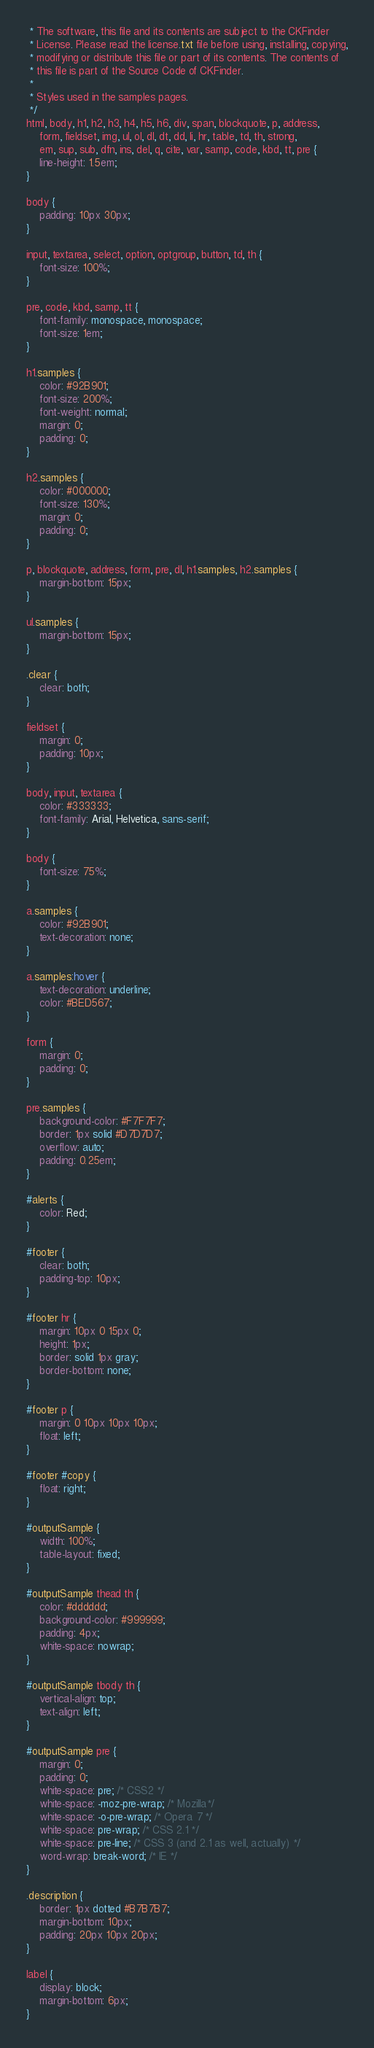Convert code to text. <code><loc_0><loc_0><loc_500><loc_500><_CSS_> * The software, this file and its contents are subject to the CKFinder
 * License. Please read the license.txt file before using, installing, copying,
 * modifying or distribute this file or part of its contents. The contents of
 * this file is part of the Source Code of CKFinder.
 *
 * Styles used in the samples pages.
 */
html, body, h1, h2, h3, h4, h5, h6, div, span, blockquote, p, address,
	form, fieldset, img, ul, ol, dl, dt, dd, li, hr, table, td, th, strong,
	em, sup, sub, dfn, ins, del, q, cite, var, samp, code, kbd, tt, pre {
	line-height: 1.5em;
}

body {
	padding: 10px 30px;
}

input, textarea, select, option, optgroup, button, td, th {
	font-size: 100%;
}

pre, code, kbd, samp, tt {
	font-family: monospace, monospace;
	font-size: 1em;
}

h1.samples {
	color: #92B901;
	font-size: 200%;
	font-weight: normal;
	margin: 0;
	padding: 0;
}

h2.samples {
	color: #000000;
	font-size: 130%;
	margin: 0;
	padding: 0;
}

p, blockquote, address, form, pre, dl, h1.samples, h2.samples {
	margin-bottom: 15px;
}

ul.samples {
	margin-bottom: 15px;
}

.clear {
	clear: both;
}

fieldset {
	margin: 0;
	padding: 10px;
}

body, input, textarea {
	color: #333333;
	font-family: Arial, Helvetica, sans-serif;
}

body {
	font-size: 75%;
}

a.samples {
	color: #92B901;
	text-decoration: none;
}

a.samples:hover {
	text-decoration: underline;
	color: #BED567;
}

form {
	margin: 0;
	padding: 0;
}

pre.samples {
	background-color: #F7F7F7;
	border: 1px solid #D7D7D7;
	overflow: auto;
	padding: 0.25em;
}

#alerts {
	color: Red;
}

#footer {
	clear: both;
	padding-top: 10px;
}

#footer hr {
	margin: 10px 0 15px 0;
	height: 1px;
	border: solid 1px gray;
	border-bottom: none;
}

#footer p {
	margin: 0 10px 10px 10px;
	float: left;
}

#footer #copy {
	float: right;
}

#outputSample {
	width: 100%;
	table-layout: fixed;
}

#outputSample thead th {
	color: #dddddd;
	background-color: #999999;
	padding: 4px;
	white-space: nowrap;
}

#outputSample tbody th {
	vertical-align: top;
	text-align: left;
}

#outputSample pre {
	margin: 0;
	padding: 0;
	white-space: pre; /* CSS2 */
	white-space: -moz-pre-wrap; /* Mozilla*/
	white-space: -o-pre-wrap; /* Opera 7 */
	white-space: pre-wrap; /* CSS 2.1 */
	white-space: pre-line; /* CSS 3 (and 2.1 as well, actually) */
	word-wrap: break-word; /* IE */
}

.description {
	border: 1px dotted #B7B7B7;
	margin-bottom: 10px;
	padding: 20px 10px 20px;
}

label {
	display: block;
	margin-bottom: 6px;
}</code> 